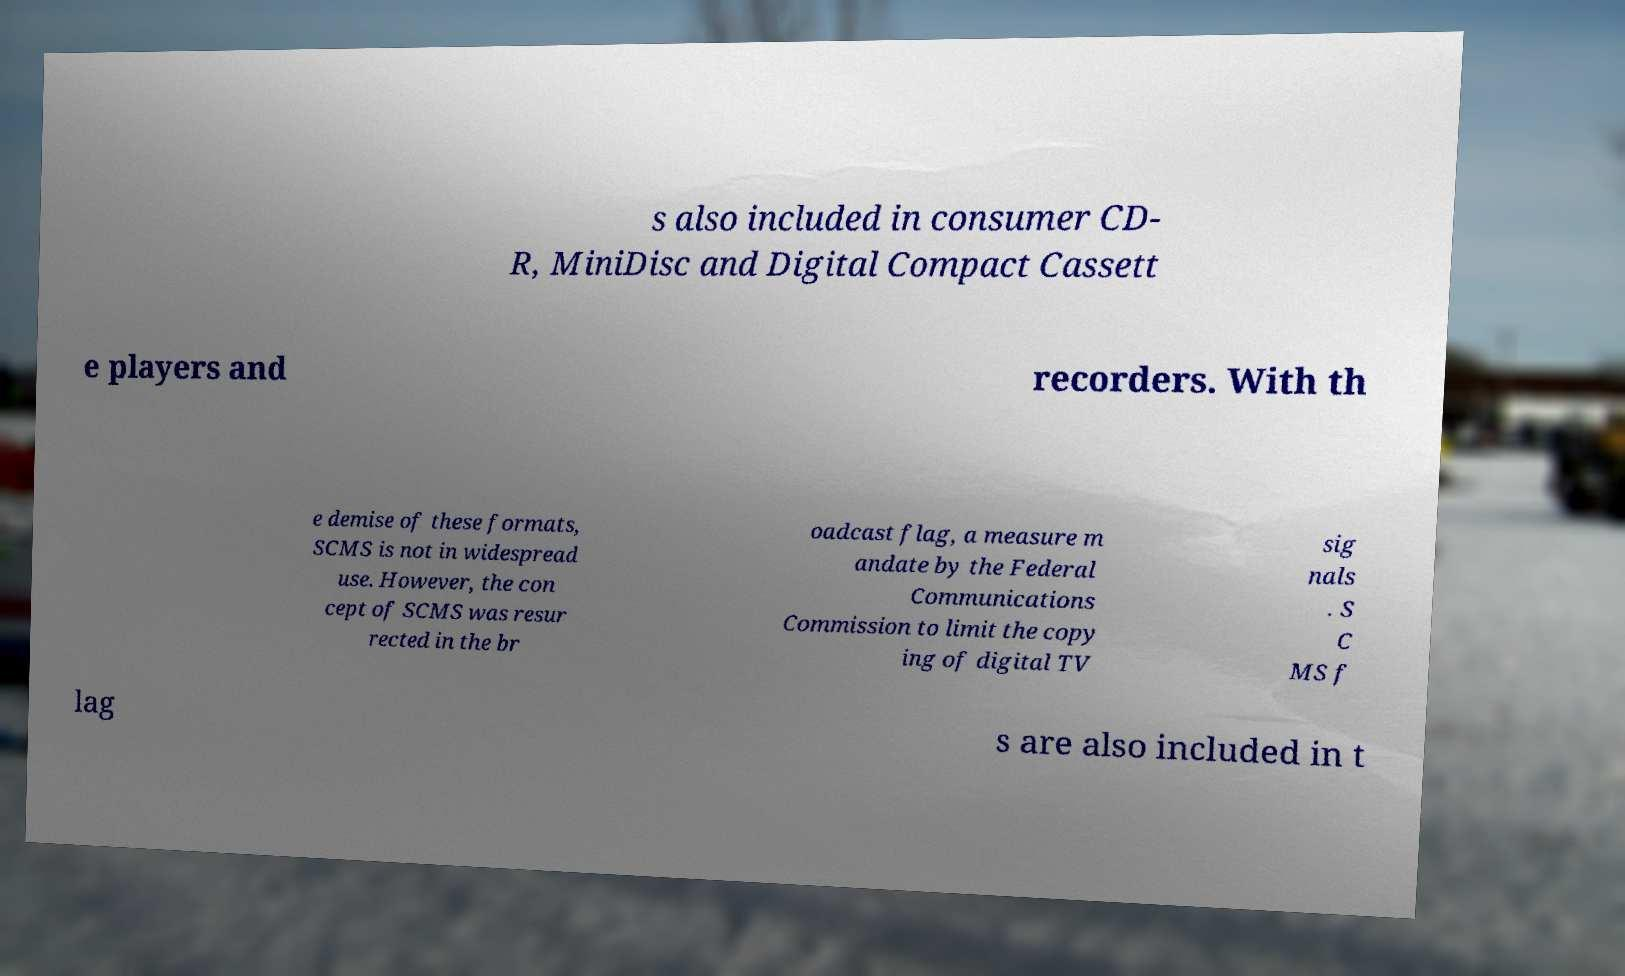Could you assist in decoding the text presented in this image and type it out clearly? s also included in consumer CD- R, MiniDisc and Digital Compact Cassett e players and recorders. With th e demise of these formats, SCMS is not in widespread use. However, the con cept of SCMS was resur rected in the br oadcast flag, a measure m andate by the Federal Communications Commission to limit the copy ing of digital TV sig nals . S C MS f lag s are also included in t 